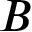<formula> <loc_0><loc_0><loc_500><loc_500>B</formula> 